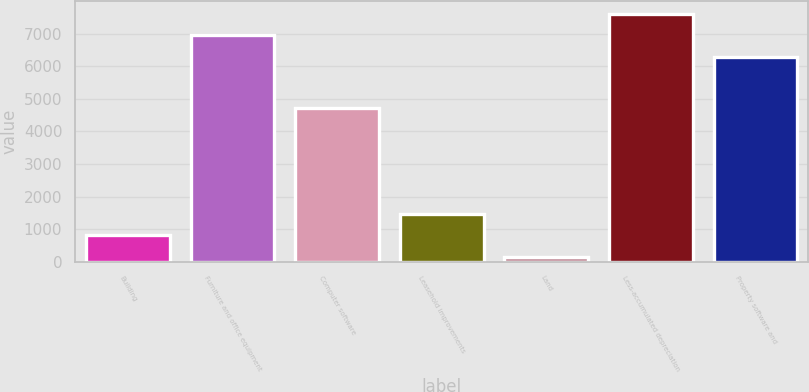Convert chart to OTSL. <chart><loc_0><loc_0><loc_500><loc_500><bar_chart><fcel>Building<fcel>Furniture and office equipment<fcel>Computer software<fcel>Leasehold improvements<fcel>Land<fcel>Less-accumulated depreciation<fcel>Property software and<nl><fcel>812<fcel>6956<fcel>4724<fcel>1473<fcel>151<fcel>7617<fcel>6295<nl></chart> 